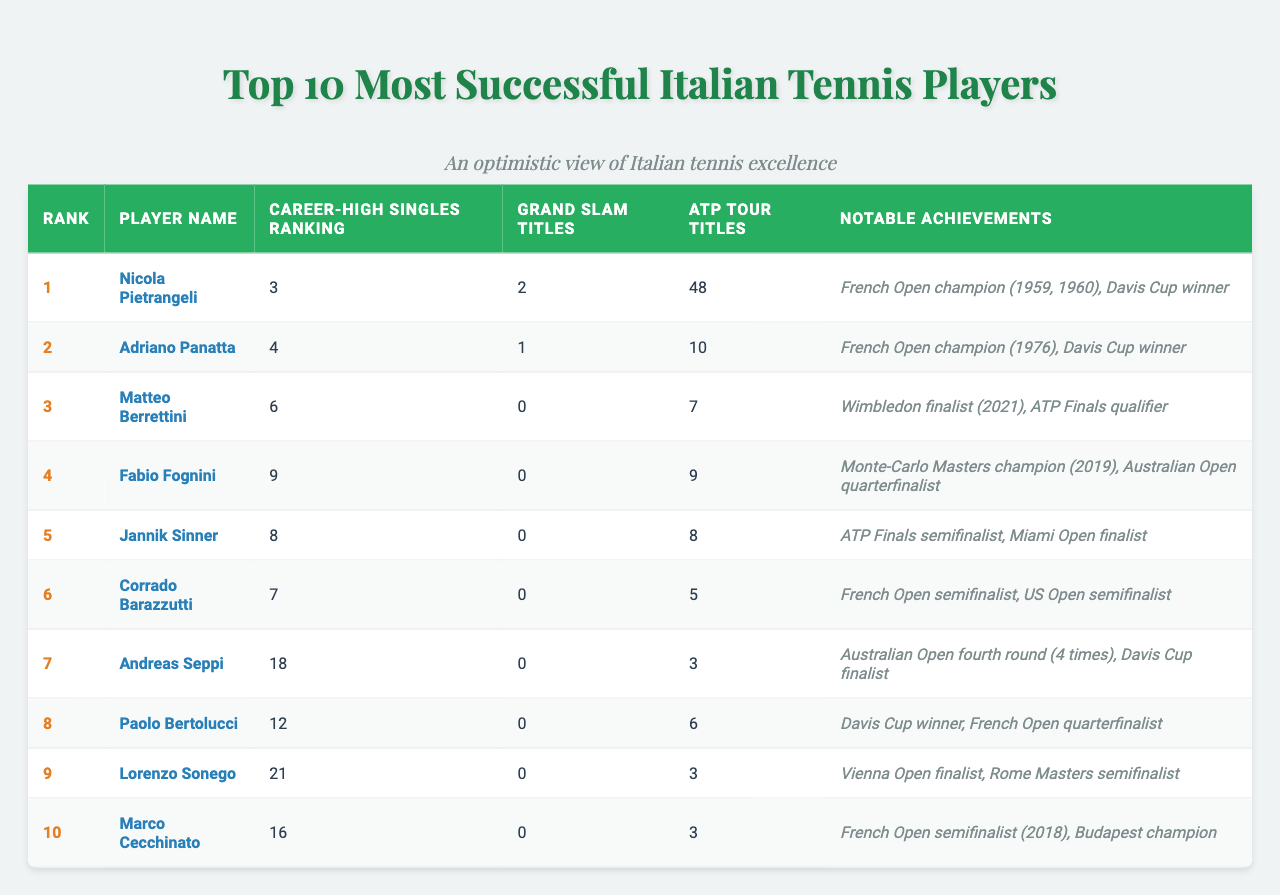What is the highest Career-High Singles Ranking achieved by an Italian player? The table shows the Career-High Singles Ranking for each player. The highest ranking is 3, achieved by Nicola Pietrangeli.
Answer: 3 How many Grand Slam titles has Fabio Fognini won? Looking at the Grand Slam Titles column, Fabio Fognini has won 0 Grand Slam titles.
Answer: 0 Which player has the most ATP Tour titles? The ATP Tour Titles column indicates that Nicola Pietrangeli has the most titles, with a total of 48.
Answer: 48 Is it true that Jannik Sinner has won a Grand Slam title? The Grand Slam Titles column for Jannik Sinner shows 0 titles, indicating he has not won any Grand Slam tournaments.
Answer: No What is the average number of ATP Tour titles among the top 10 players? To find the average, sum the ATP Tour Titles (48 + 10 + 7 + 9 + 8 + 5 + 3 + 6 + 3 + 3 = 98) and divide by the number of players (10). Thus, 98/10 = 9.8.
Answer: 9.8 Which player had the best notable achievement apart from Grand Slam titles? The notable achievements indicate that Nicola Pietrangeli's accomplishments include being a Davis Cup winner and a two-time French Open champion, which are significant in the context.
Answer: Nicola Pietrangeli How many players have achieved a Career-High Singles Ranking within the top 10? By reviewing the Career-High Singles Ranking, all players listed in the table are within the top 21, but only 7 players are ranked within the top 10.
Answer: 7 Did any player reach their Career-High singles ranking in 2021? The table shows that Matteo Berrettini reached a Career-High in 2021 when he became the Wimbledon finalist, but no specific ranking date is mentioned. Hence, it's unclear.
Answer: Uncertain How many players have not won any Grand Slam titles among the top 10? The table lists 7 players (Matteo Berrettini, Fabio Fognini, Jannik Sinner, Corrado Barazzutti, Andreas Seppi, Paolo Bertolucci, Lorenzo Sonego, Marco Cecchinato) who have 0 Grand Slam titles from the total of 10 players.
Answer: 8 Which player has the most notable achievements related to Grand Slam performances? Nicola Pietrangeli and Adriano Panatta have significant achievements, but Nicola Pietrangeli wins with two Grand Slam titles, making him stand out in this aspect.
Answer: Nicola Pietrangeli 